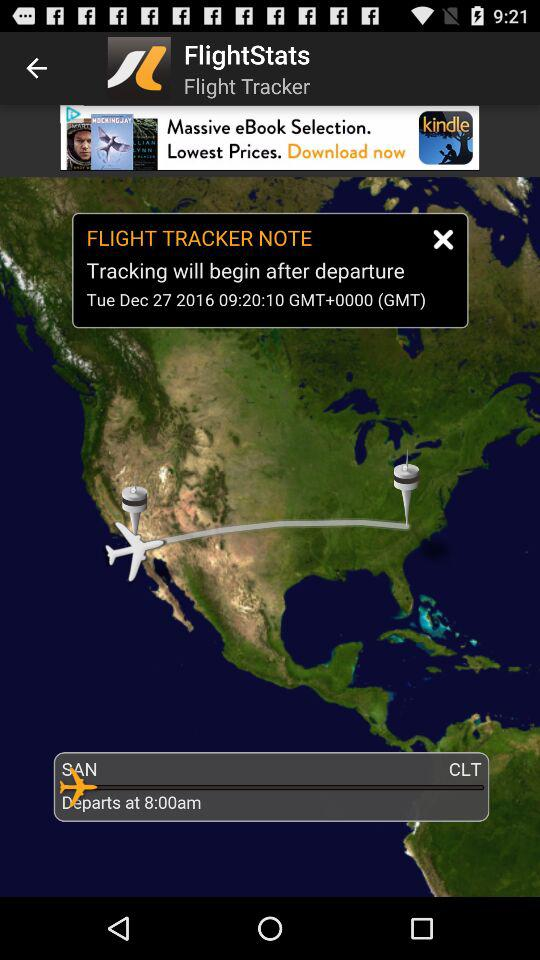What is the departure location? The departure location is San Diego. 